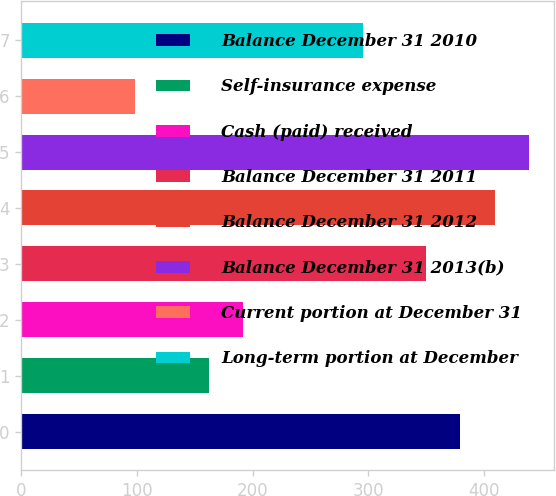Convert chart to OTSL. <chart><loc_0><loc_0><loc_500><loc_500><bar_chart><fcel>Balance December 31 2010<fcel>Self-insurance expense<fcel>Cash (paid) received<fcel>Balance December 31 2011<fcel>Balance December 31 2012<fcel>Balance December 31 2013(b)<fcel>Current portion at December 31<fcel>Long-term portion at December<nl><fcel>379.5<fcel>162<fcel>191.5<fcel>350<fcel>409<fcel>438.5<fcel>98<fcel>295<nl></chart> 